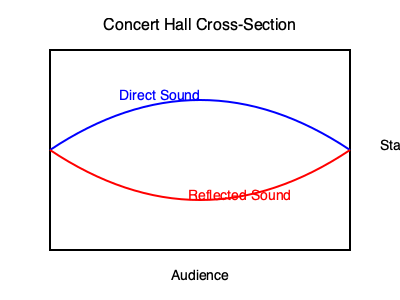In a concert hall designed for piano performances, the time delay between the arrival of direct sound and first reflections at the audience's ears is crucial for acoustic quality. If the speed of sound is 343 m/s, and the difference in path length between direct and reflected sound is 17 meters, what is the time delay in milliseconds? How might this delay affect the perception of the piano's sound? To solve this problem and understand its implications, let's follow these steps:

1. Calculate the time delay:
   - Speed of sound = 343 m/s
   - Difference in path length = 17 m
   - Time = Distance / Speed
   - Time delay = 17 m / 343 m/s
   - Time delay = 0.0495 s = 49.5 ms

2. Implications for piano sound perception:
   a) The calculated delay of 49.5 ms falls within the range of what is known as the "Haas effect" or "precedence effect" (typically 20-50 ms).
   
   b) This delay can contribute to a sense of spaciousness and envelopment, enhancing the perceived quality of the piano sound.
   
   c) For a piano, this delay can help blend the initial transients with the sustained tones, potentially enriching the overall timbre.
   
   d) However, if the delay is too long (generally over 50-80 ms), it might be perceived as a distinct echo, which could interfere with the clarity of the performance.
   
   e) The optimal delay time can vary depending on the specific musical piece and style being performed. For instance, faster passages might benefit from shorter delay times to maintain clarity.
   
   f) Concert hall designers must balance this delay with other acoustic parameters like reverberation time, early decay time, and frequency response to achieve optimal conditions for piano performances.

3. Considerations for pianists:
   - Understanding this acoustic property allows pianists to adjust their playing technique, potentially using the hall's acoustics to enhance their performance.
   - They might slightly adjust timing or pedaling to work with the hall's acoustic response, especially in more resonant passages.

The 49.5 ms delay in this case would generally be considered favorable for piano performances, providing a sense of warmth and spaciousness without compromising clarity.
Answer: 49.5 ms; enhances spaciousness without compromising clarity. 